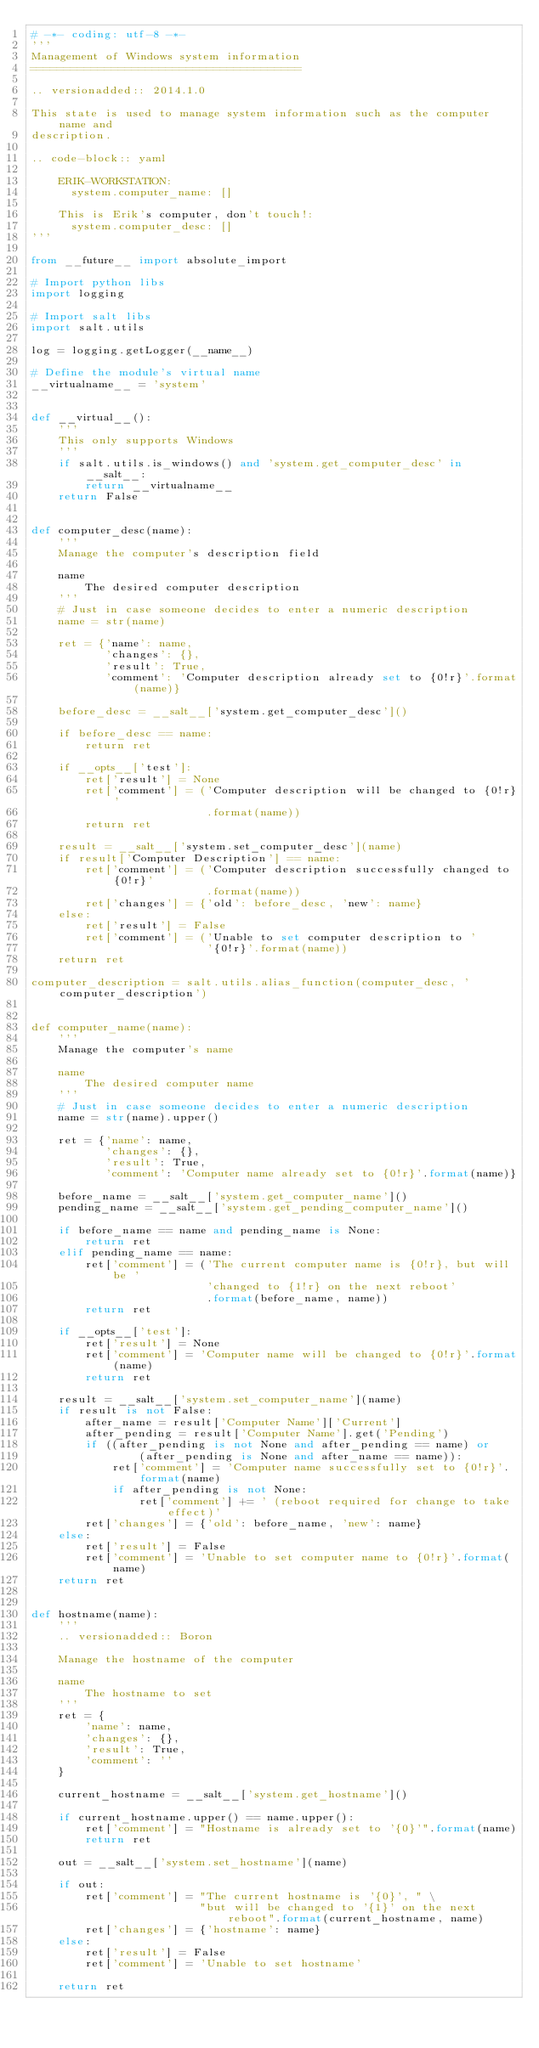Convert code to text. <code><loc_0><loc_0><loc_500><loc_500><_Python_># -*- coding: utf-8 -*-
'''
Management of Windows system information
========================================

.. versionadded:: 2014.1.0

This state is used to manage system information such as the computer name and
description.

.. code-block:: yaml

    ERIK-WORKSTATION:
      system.computer_name: []

    This is Erik's computer, don't touch!:
      system.computer_desc: []
'''

from __future__ import absolute_import

# Import python libs
import logging

# Import salt libs
import salt.utils

log = logging.getLogger(__name__)

# Define the module's virtual name
__virtualname__ = 'system'


def __virtual__():
    '''
    This only supports Windows
    '''
    if salt.utils.is_windows() and 'system.get_computer_desc' in __salt__:
        return __virtualname__
    return False


def computer_desc(name):
    '''
    Manage the computer's description field

    name
        The desired computer description
    '''
    # Just in case someone decides to enter a numeric description
    name = str(name)

    ret = {'name': name,
           'changes': {},
           'result': True,
           'comment': 'Computer description already set to {0!r}'.format(name)}

    before_desc = __salt__['system.get_computer_desc']()

    if before_desc == name:
        return ret

    if __opts__['test']:
        ret['result'] = None
        ret['comment'] = ('Computer description will be changed to {0!r}'
                          .format(name))
        return ret

    result = __salt__['system.set_computer_desc'](name)
    if result['Computer Description'] == name:
        ret['comment'] = ('Computer description successfully changed to {0!r}'
                          .format(name))
        ret['changes'] = {'old': before_desc, 'new': name}
    else:
        ret['result'] = False
        ret['comment'] = ('Unable to set computer description to '
                          '{0!r}'.format(name))
    return ret

computer_description = salt.utils.alias_function(computer_desc, 'computer_description')


def computer_name(name):
    '''
    Manage the computer's name

    name
        The desired computer name
    '''
    # Just in case someone decides to enter a numeric description
    name = str(name).upper()

    ret = {'name': name,
           'changes': {},
           'result': True,
           'comment': 'Computer name already set to {0!r}'.format(name)}

    before_name = __salt__['system.get_computer_name']()
    pending_name = __salt__['system.get_pending_computer_name']()

    if before_name == name and pending_name is None:
        return ret
    elif pending_name == name:
        ret['comment'] = ('The current computer name is {0!r}, but will be '
                          'changed to {1!r} on the next reboot'
                          .format(before_name, name))
        return ret

    if __opts__['test']:
        ret['result'] = None
        ret['comment'] = 'Computer name will be changed to {0!r}'.format(name)
        return ret

    result = __salt__['system.set_computer_name'](name)
    if result is not False:
        after_name = result['Computer Name']['Current']
        after_pending = result['Computer Name'].get('Pending')
        if ((after_pending is not None and after_pending == name) or
                (after_pending is None and after_name == name)):
            ret['comment'] = 'Computer name successfully set to {0!r}'.format(name)
            if after_pending is not None:
                ret['comment'] += ' (reboot required for change to take effect)'
        ret['changes'] = {'old': before_name, 'new': name}
    else:
        ret['result'] = False
        ret['comment'] = 'Unable to set computer name to {0!r}'.format(name)
    return ret


def hostname(name):
    '''
    .. versionadded:: Boron

    Manage the hostname of the computer

    name
        The hostname to set
    '''
    ret = {
        'name': name,
        'changes': {},
        'result': True,
        'comment': ''
    }

    current_hostname = __salt__['system.get_hostname']()

    if current_hostname.upper() == name.upper():
        ret['comment'] = "Hostname is already set to '{0}'".format(name)
        return ret

    out = __salt__['system.set_hostname'](name)

    if out:
        ret['comment'] = "The current hostname is '{0}', " \
                         "but will be changed to '{1}' on the next reboot".format(current_hostname, name)
        ret['changes'] = {'hostname': name}
    else:
        ret['result'] = False
        ret['comment'] = 'Unable to set hostname'

    return ret
</code> 